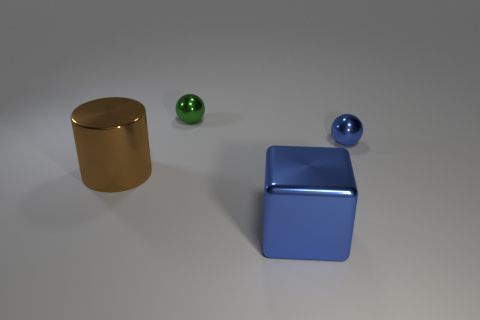Do the sphere to the right of the green ball and the green object have the same size?
Offer a very short reply. Yes. How many other objects are there of the same material as the big brown object?
Your answer should be compact. 3. What number of blue things are either small things or large things?
Make the answer very short. 2. The object that is the same color as the shiny block is what size?
Offer a terse response. Small. What number of balls are to the right of the tiny green metal ball?
Your answer should be compact. 1. There is a blue metallic object that is in front of the tiny shiny object in front of the thing that is behind the small blue metallic sphere; how big is it?
Make the answer very short. Large. There is a object that is on the right side of the large blue thing in front of the big cylinder; are there any balls that are left of it?
Give a very brief answer. Yes. Is the number of small spheres greater than the number of objects?
Your response must be concise. No. The large shiny thing in front of the brown thing is what color?
Offer a terse response. Blue. Is the number of tiny green metallic spheres that are behind the brown metal thing greater than the number of large cyan metal blocks?
Your answer should be very brief. Yes. 